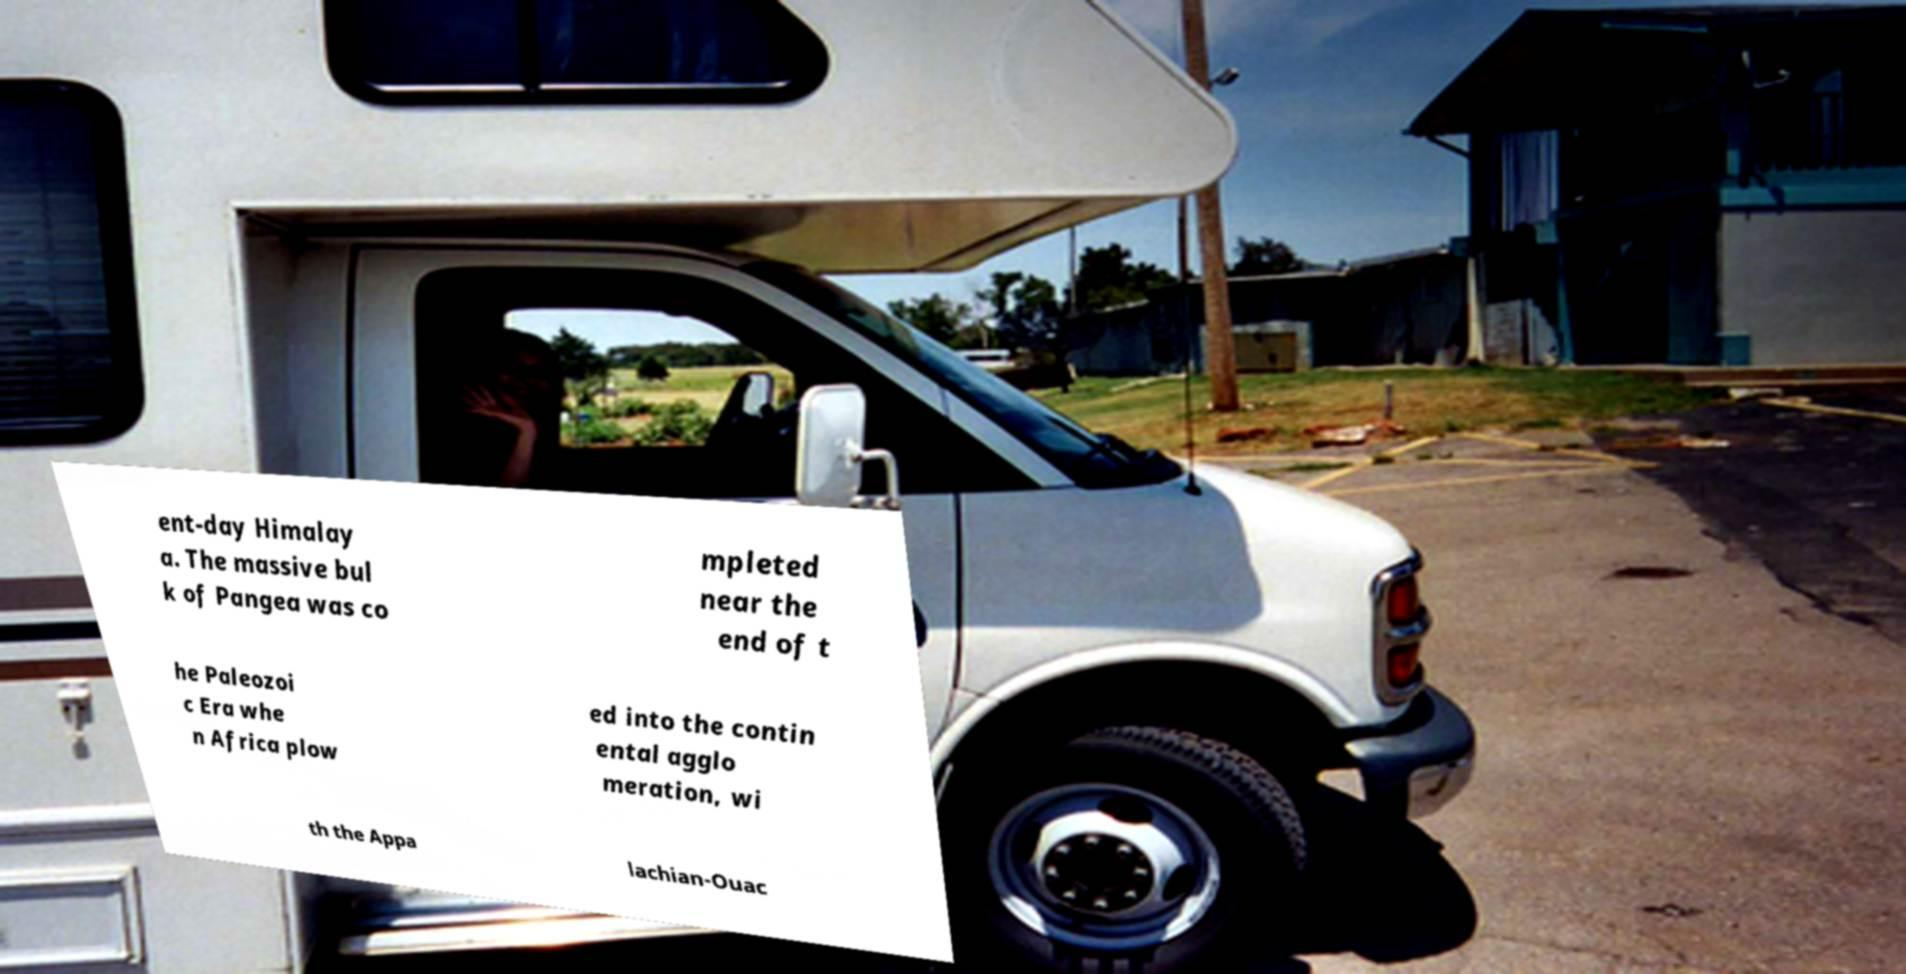Please identify and transcribe the text found in this image. ent-day Himalay a. The massive bul k of Pangea was co mpleted near the end of t he Paleozoi c Era whe n Africa plow ed into the contin ental agglo meration, wi th the Appa lachian-Ouac 